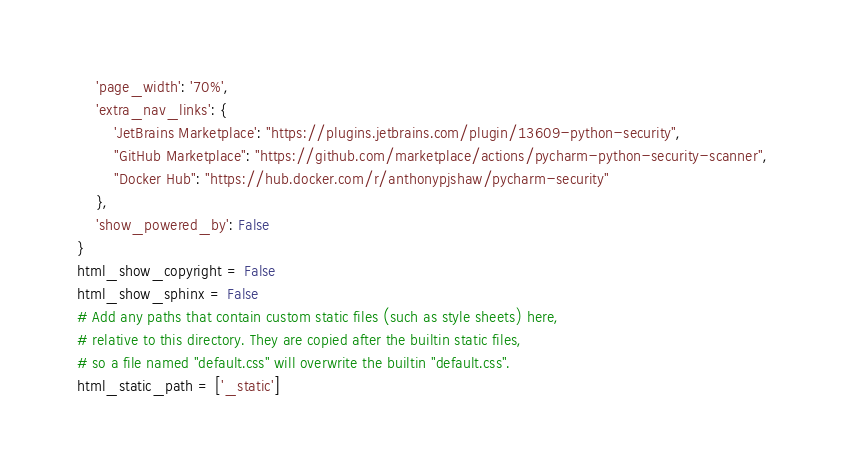<code> <loc_0><loc_0><loc_500><loc_500><_Python_>    'page_width': '70%',
    'extra_nav_links': {
        'JetBrains Marketplace': "https://plugins.jetbrains.com/plugin/13609-python-security",
        "GitHub Marketplace": "https://github.com/marketplace/actions/pycharm-python-security-scanner",
        "Docker Hub": "https://hub.docker.com/r/anthonypjshaw/pycharm-security"
    },
    'show_powered_by': False
}
html_show_copyright = False
html_show_sphinx = False
# Add any paths that contain custom static files (such as style sheets) here,
# relative to this directory. They are copied after the builtin static files,
# so a file named "default.css" will overwrite the builtin "default.css".
html_static_path = ['_static']</code> 